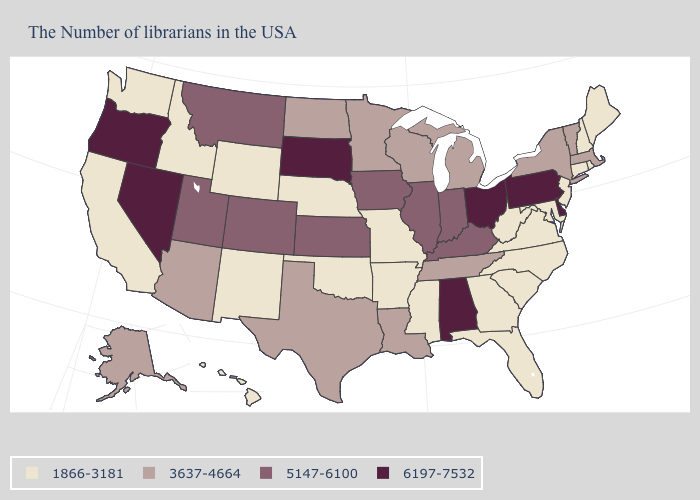Name the states that have a value in the range 1866-3181?
Be succinct. Maine, Rhode Island, New Hampshire, Connecticut, New Jersey, Maryland, Virginia, North Carolina, South Carolina, West Virginia, Florida, Georgia, Mississippi, Missouri, Arkansas, Nebraska, Oklahoma, Wyoming, New Mexico, Idaho, California, Washington, Hawaii. Name the states that have a value in the range 1866-3181?
Be succinct. Maine, Rhode Island, New Hampshire, Connecticut, New Jersey, Maryland, Virginia, North Carolina, South Carolina, West Virginia, Florida, Georgia, Mississippi, Missouri, Arkansas, Nebraska, Oklahoma, Wyoming, New Mexico, Idaho, California, Washington, Hawaii. Name the states that have a value in the range 3637-4664?
Answer briefly. Massachusetts, Vermont, New York, Michigan, Tennessee, Wisconsin, Louisiana, Minnesota, Texas, North Dakota, Arizona, Alaska. What is the value of Utah?
Concise answer only. 5147-6100. Name the states that have a value in the range 6197-7532?
Keep it brief. Delaware, Pennsylvania, Ohio, Alabama, South Dakota, Nevada, Oregon. Among the states that border Texas , which have the highest value?
Short answer required. Louisiana. What is the highest value in states that border North Carolina?
Quick response, please. 3637-4664. Does the first symbol in the legend represent the smallest category?
Keep it brief. Yes. Which states have the lowest value in the South?
Keep it brief. Maryland, Virginia, North Carolina, South Carolina, West Virginia, Florida, Georgia, Mississippi, Arkansas, Oklahoma. Does Wisconsin have the lowest value in the USA?
Short answer required. No. What is the value of Nevada?
Concise answer only. 6197-7532. How many symbols are there in the legend?
Answer briefly. 4. What is the value of Hawaii?
Give a very brief answer. 1866-3181. How many symbols are there in the legend?
Keep it brief. 4. What is the value of Kentucky?
Write a very short answer. 5147-6100. 